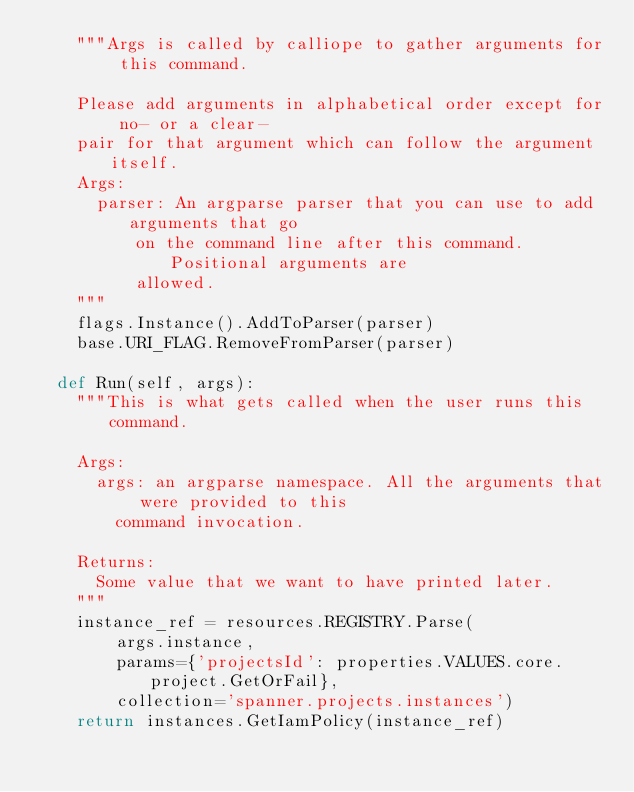<code> <loc_0><loc_0><loc_500><loc_500><_Python_>    """Args is called by calliope to gather arguments for this command.

    Please add arguments in alphabetical order except for no- or a clear-
    pair for that argument which can follow the argument itself.
    Args:
      parser: An argparse parser that you can use to add arguments that go
          on the command line after this command. Positional arguments are
          allowed.
    """
    flags.Instance().AddToParser(parser)
    base.URI_FLAG.RemoveFromParser(parser)

  def Run(self, args):
    """This is what gets called when the user runs this command.

    Args:
      args: an argparse namespace. All the arguments that were provided to this
        command invocation.

    Returns:
      Some value that we want to have printed later.
    """
    instance_ref = resources.REGISTRY.Parse(
        args.instance,
        params={'projectsId': properties.VALUES.core.project.GetOrFail},
        collection='spanner.projects.instances')
    return instances.GetIamPolicy(instance_ref)
</code> 